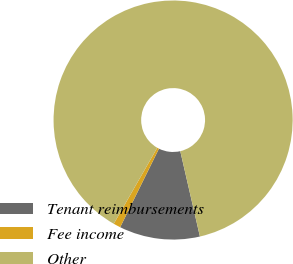Convert chart to OTSL. <chart><loc_0><loc_0><loc_500><loc_500><pie_chart><fcel>Tenant reimbursements<fcel>Fee income<fcel>Other<nl><fcel>10.9%<fcel>0.97%<fcel>88.13%<nl></chart> 